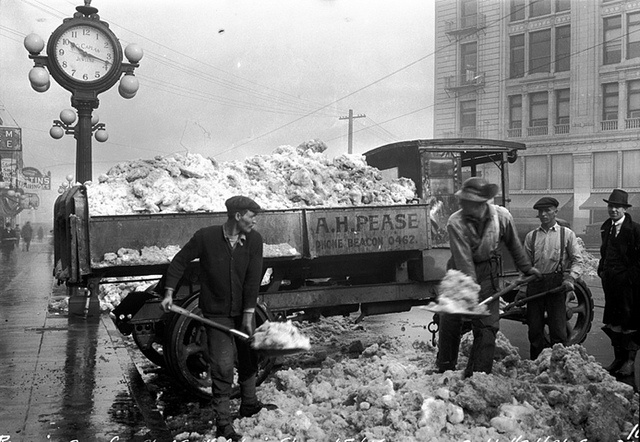Describe the objects in this image and their specific colors. I can see truck in lightgray, black, gray, and darkgray tones, people in lightgray, black, gray, and darkgray tones, people in lightgray, black, gray, and darkgray tones, people in lightgray, black, gray, and darkgray tones, and people in lightgray, black, gray, and darkgray tones in this image. 